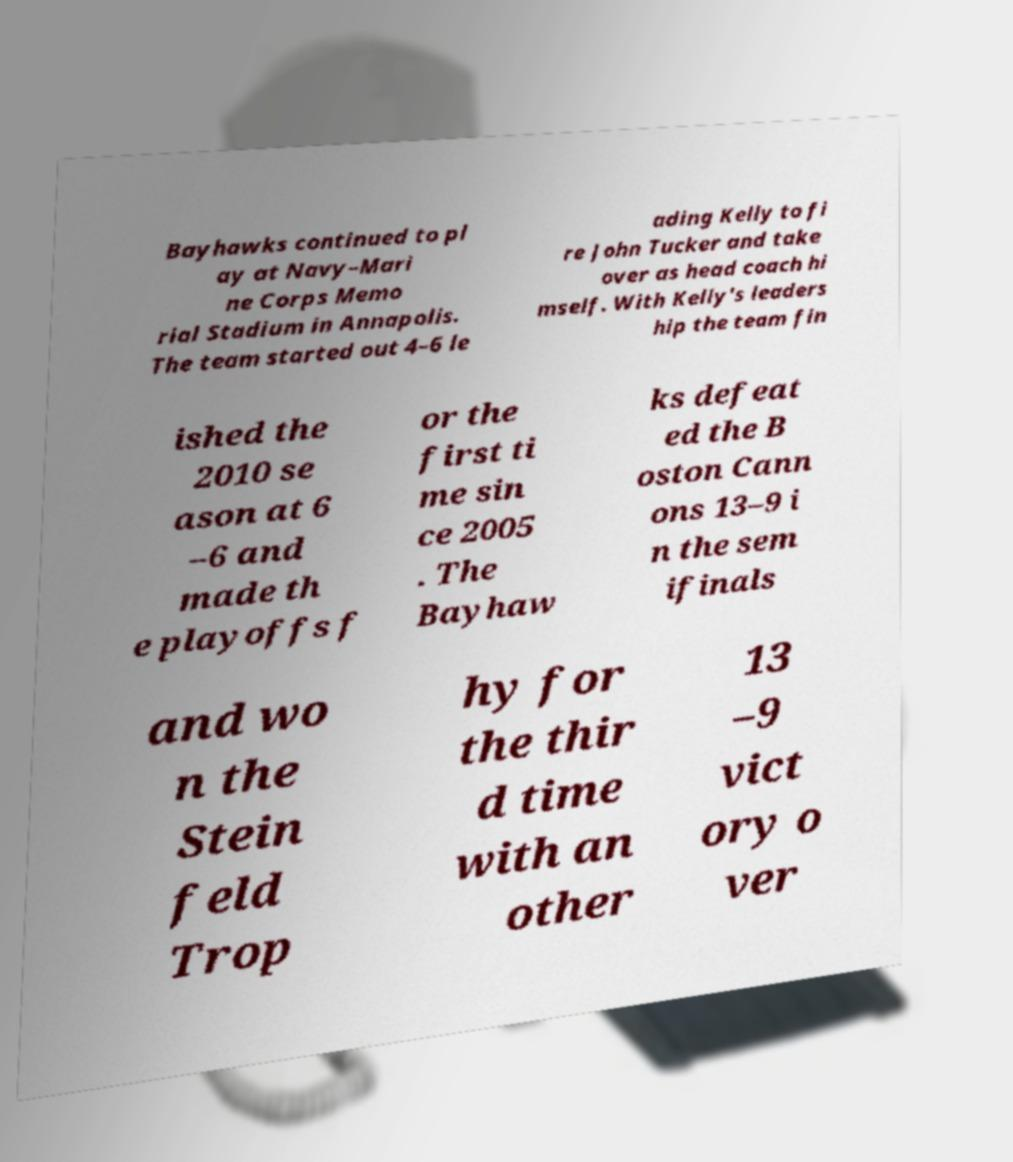What messages or text are displayed in this image? I need them in a readable, typed format. Bayhawks continued to pl ay at Navy–Mari ne Corps Memo rial Stadium in Annapolis. The team started out 4–6 le ading Kelly to fi re John Tucker and take over as head coach hi mself. With Kelly's leaders hip the team fin ished the 2010 se ason at 6 –6 and made th e playoffs f or the first ti me sin ce 2005 . The Bayhaw ks defeat ed the B oston Cann ons 13–9 i n the sem ifinals and wo n the Stein feld Trop hy for the thir d time with an other 13 –9 vict ory o ver 